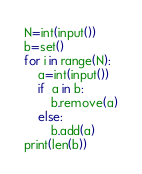<code> <loc_0><loc_0><loc_500><loc_500><_Python_>N=int(input())
b=set()
for i in range(N):
    a=int(input())
    if  a in b:
        b.remove(a)
    else:
        b.add(a)
print(len(b))</code> 